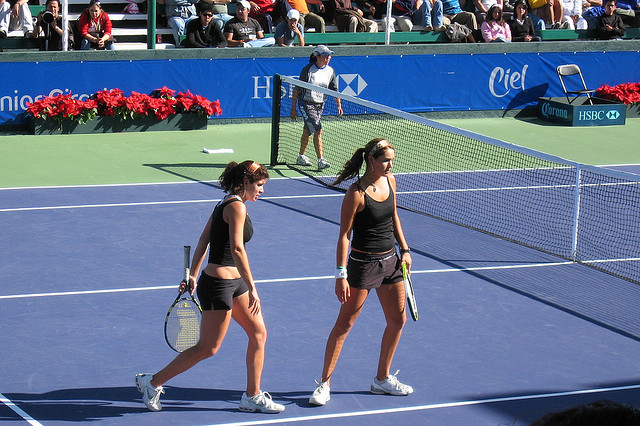How would you describe the body language of the players? The players appear to be walking with a purposeful stride, which might suggest that they are focused and possibly strategizing for the next part of their match. Their facial expressions do not convey distinct emotions, so it's challenging to state conclusively whether they are feeling positive or negative at this moment. 